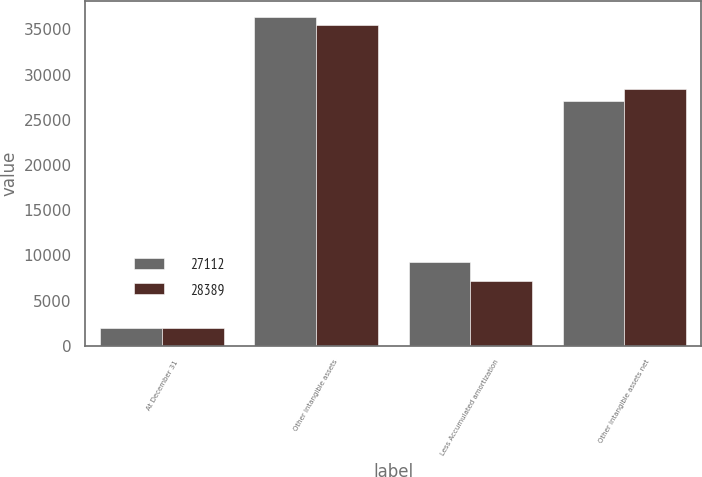Convert chart. <chart><loc_0><loc_0><loc_500><loc_500><stacked_bar_chart><ecel><fcel>At December 31<fcel>Other intangible assets<fcel>Less Accumulated amortization<fcel>Other intangible assets net<nl><fcel>27112<fcel>2013<fcel>36352<fcel>9240<fcel>27112<nl><fcel>28389<fcel>2012<fcel>35515<fcel>7126<fcel>28389<nl></chart> 